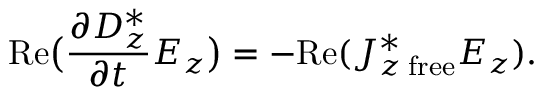<formula> <loc_0><loc_0><loc_500><loc_500>R e \left ( { \frac { \partial D _ { z } ^ { * } } { \partial t } } E _ { z } \right ) = - R e ( J _ { z \, f r e e } ^ { * } E _ { z } ) .</formula> 